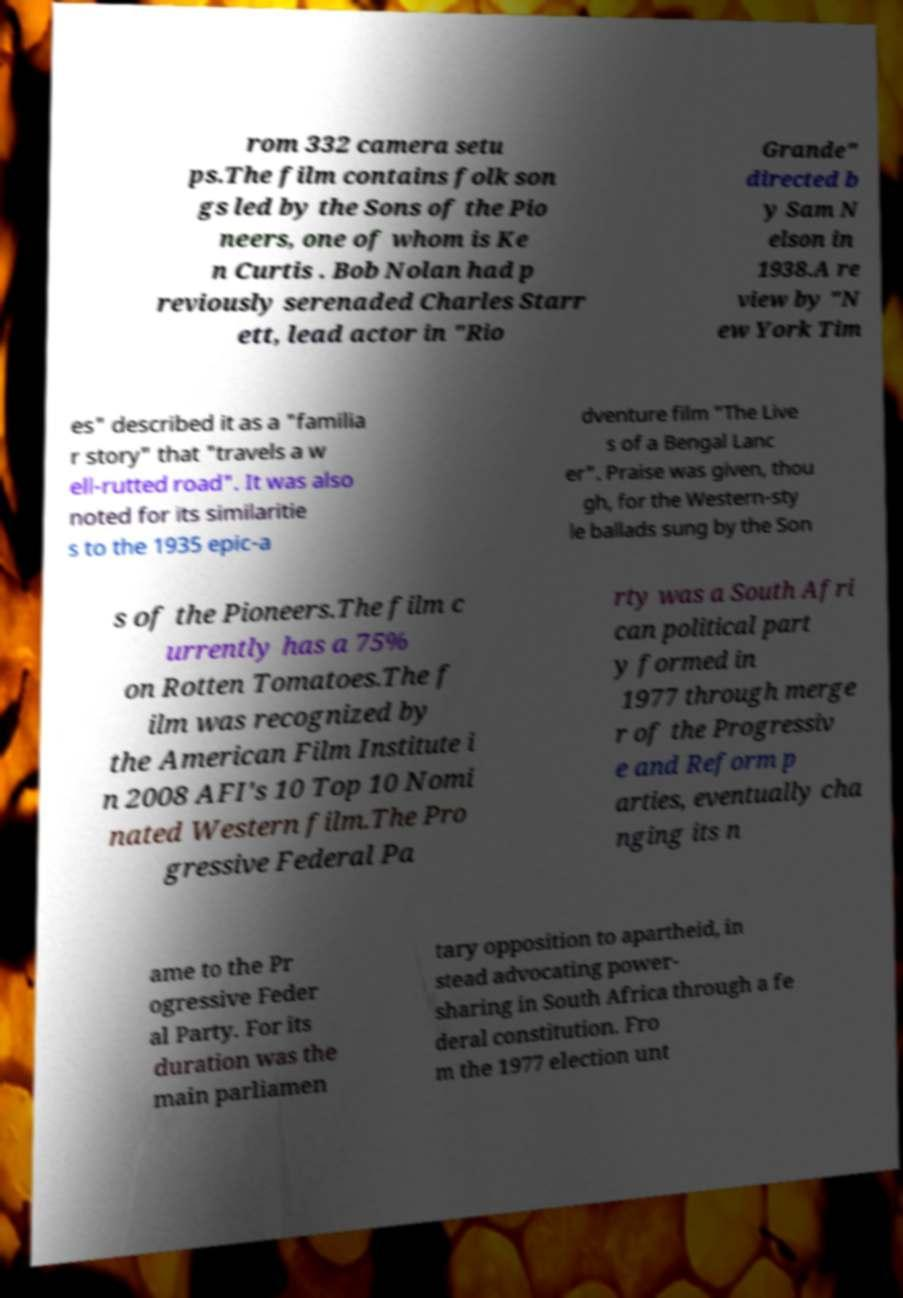For documentation purposes, I need the text within this image transcribed. Could you provide that? rom 332 camera setu ps.The film contains folk son gs led by the Sons of the Pio neers, one of whom is Ke n Curtis . Bob Nolan had p reviously serenaded Charles Starr ett, lead actor in "Rio Grande" directed b y Sam N elson in 1938.A re view by "N ew York Tim es" described it as a "familia r story" that "travels a w ell-rutted road". It was also noted for its similaritie s to the 1935 epic-a dventure film "The Live s of a Bengal Lanc er". Praise was given, thou gh, for the Western-sty le ballads sung by the Son s of the Pioneers.The film c urrently has a 75% on Rotten Tomatoes.The f ilm was recognized by the American Film Institute i n 2008 AFI's 10 Top 10 Nomi nated Western film.The Pro gressive Federal Pa rty was a South Afri can political part y formed in 1977 through merge r of the Progressiv e and Reform p arties, eventually cha nging its n ame to the Pr ogressive Feder al Party. For its duration was the main parliamen tary opposition to apartheid, in stead advocating power- sharing in South Africa through a fe deral constitution. Fro m the 1977 election unt 